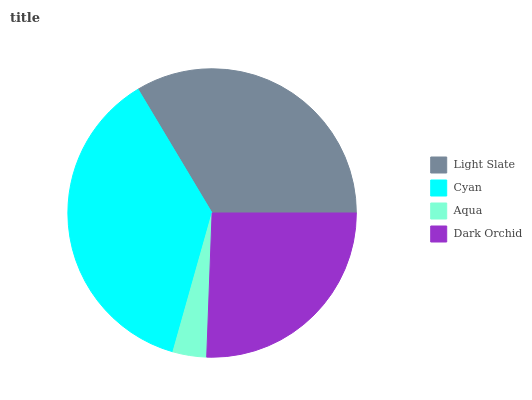Is Aqua the minimum?
Answer yes or no. Yes. Is Cyan the maximum?
Answer yes or no. Yes. Is Cyan the minimum?
Answer yes or no. No. Is Aqua the maximum?
Answer yes or no. No. Is Cyan greater than Aqua?
Answer yes or no. Yes. Is Aqua less than Cyan?
Answer yes or no. Yes. Is Aqua greater than Cyan?
Answer yes or no. No. Is Cyan less than Aqua?
Answer yes or no. No. Is Light Slate the high median?
Answer yes or no. Yes. Is Dark Orchid the low median?
Answer yes or no. Yes. Is Dark Orchid the high median?
Answer yes or no. No. Is Cyan the low median?
Answer yes or no. No. 